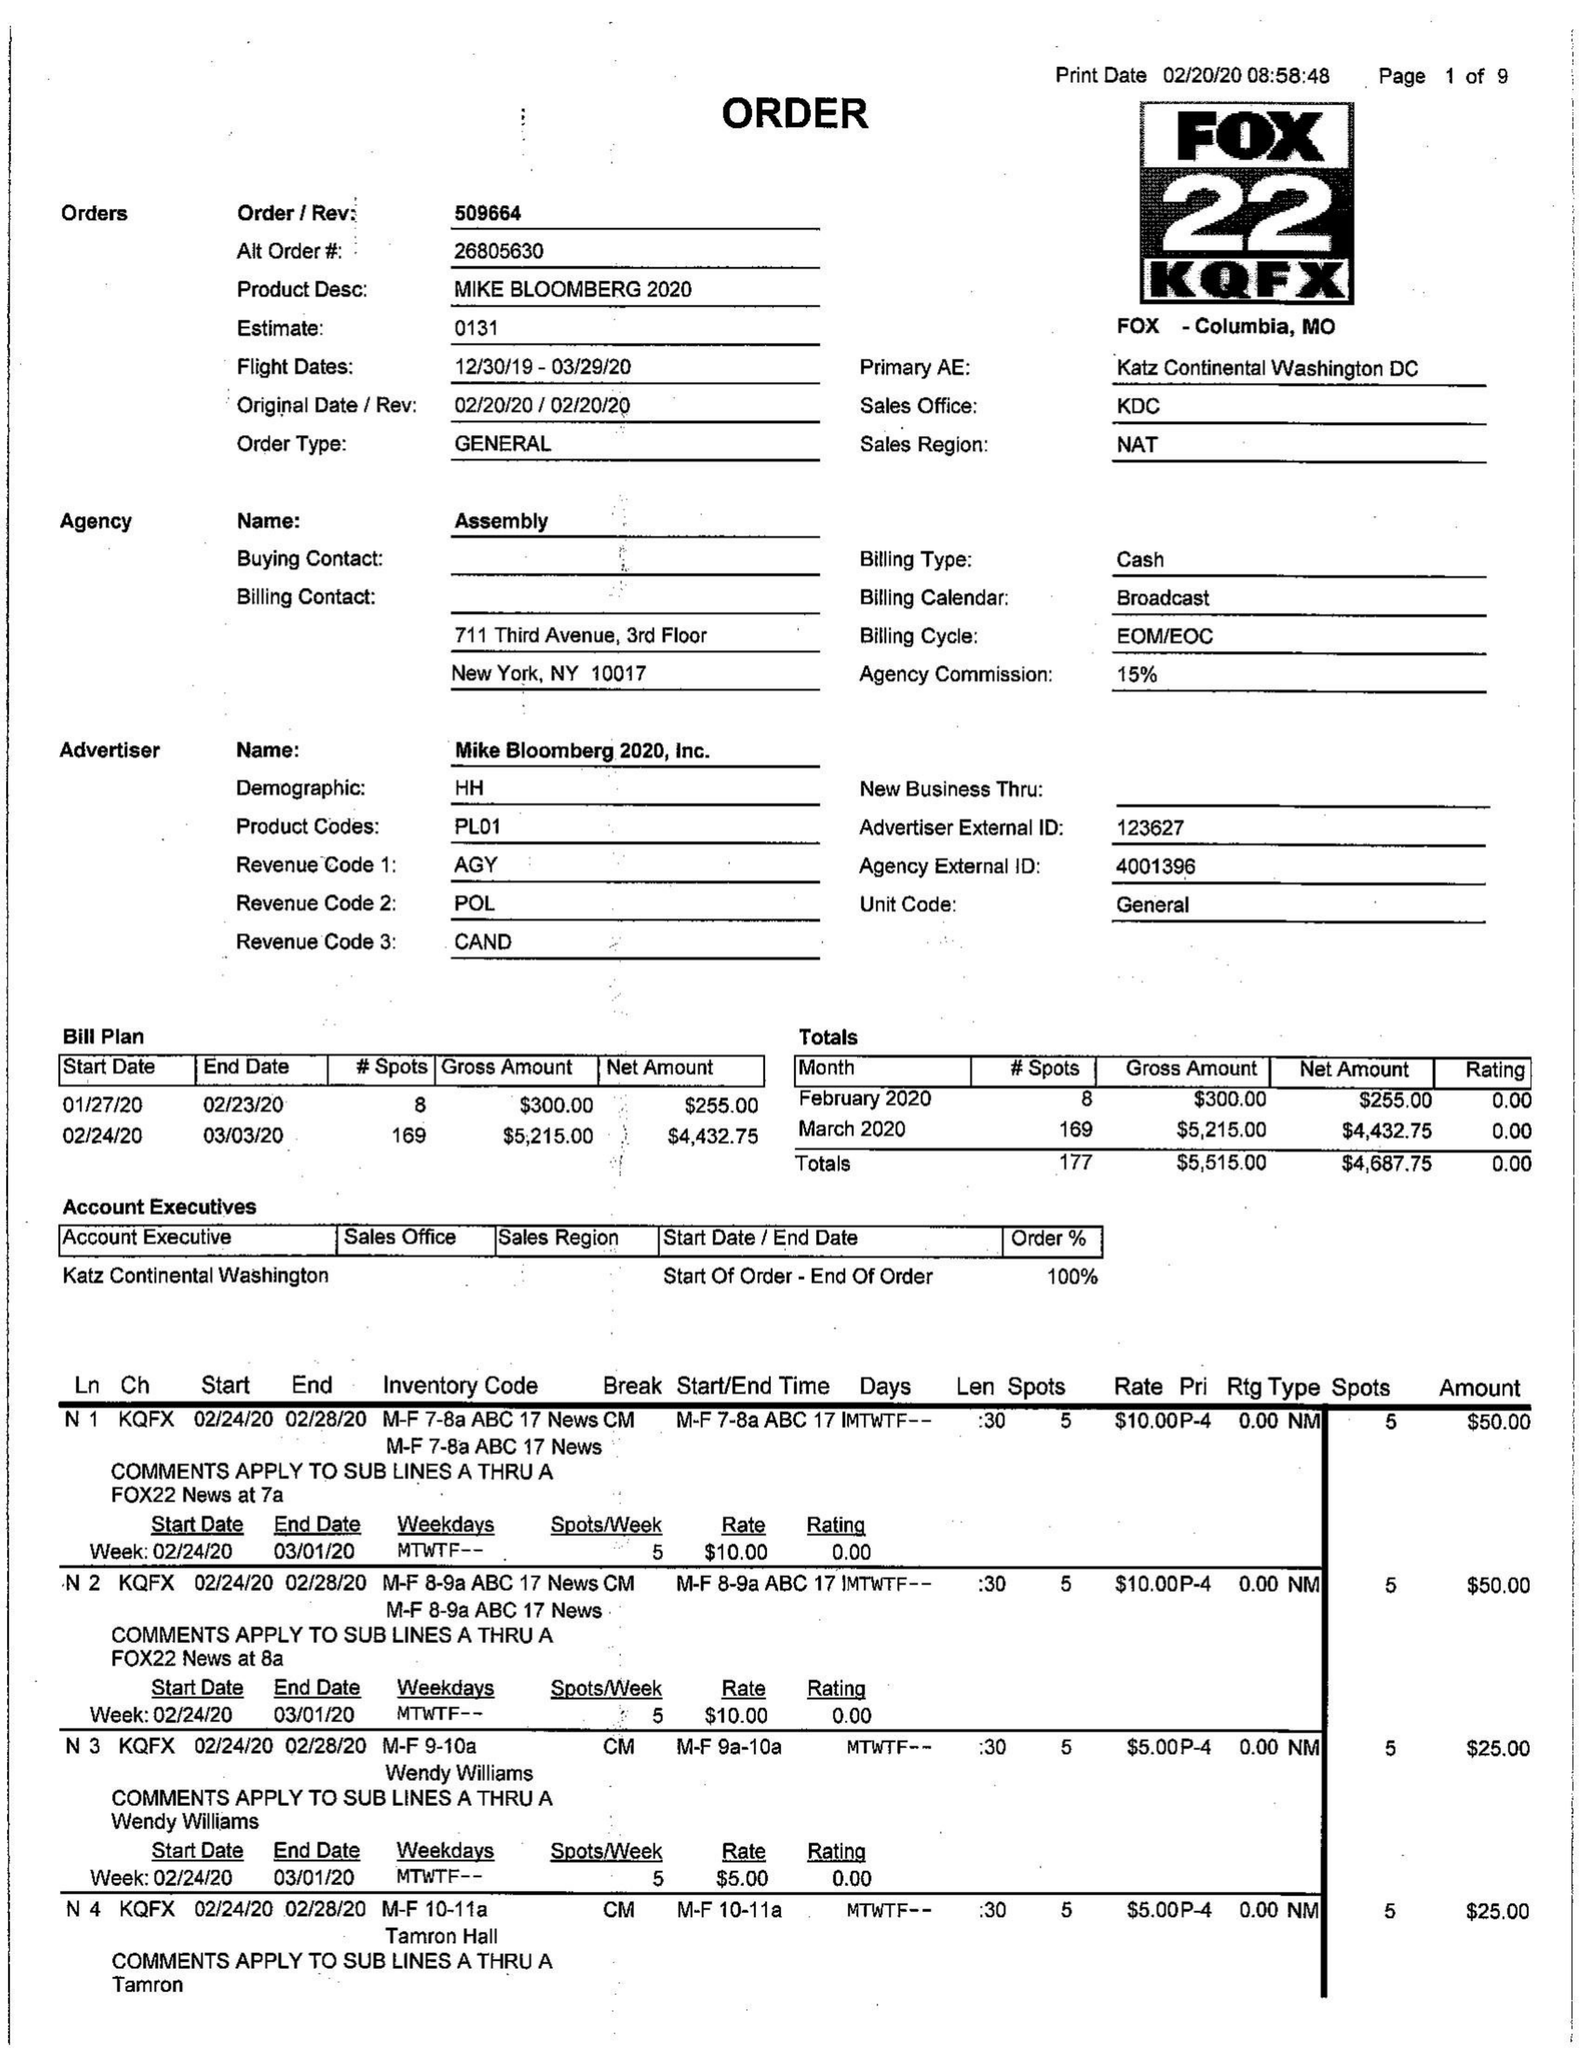What is the value for the flight_from?
Answer the question using a single word or phrase. 12/30/19 